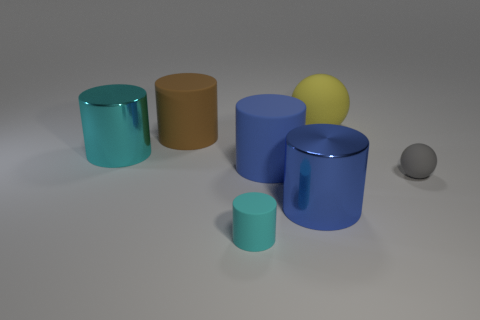Subtract all brown cylinders. How many cylinders are left? 4 Subtract all large brown cylinders. How many cylinders are left? 4 Subtract 1 cylinders. How many cylinders are left? 4 Subtract all gray cylinders. Subtract all yellow balls. How many cylinders are left? 5 Add 3 large blue shiny cylinders. How many objects exist? 10 Subtract all balls. How many objects are left? 5 Subtract all large matte spheres. Subtract all large purple metal things. How many objects are left? 6 Add 6 shiny things. How many shiny things are left? 8 Add 4 big brown cylinders. How many big brown cylinders exist? 5 Subtract 0 cyan spheres. How many objects are left? 7 